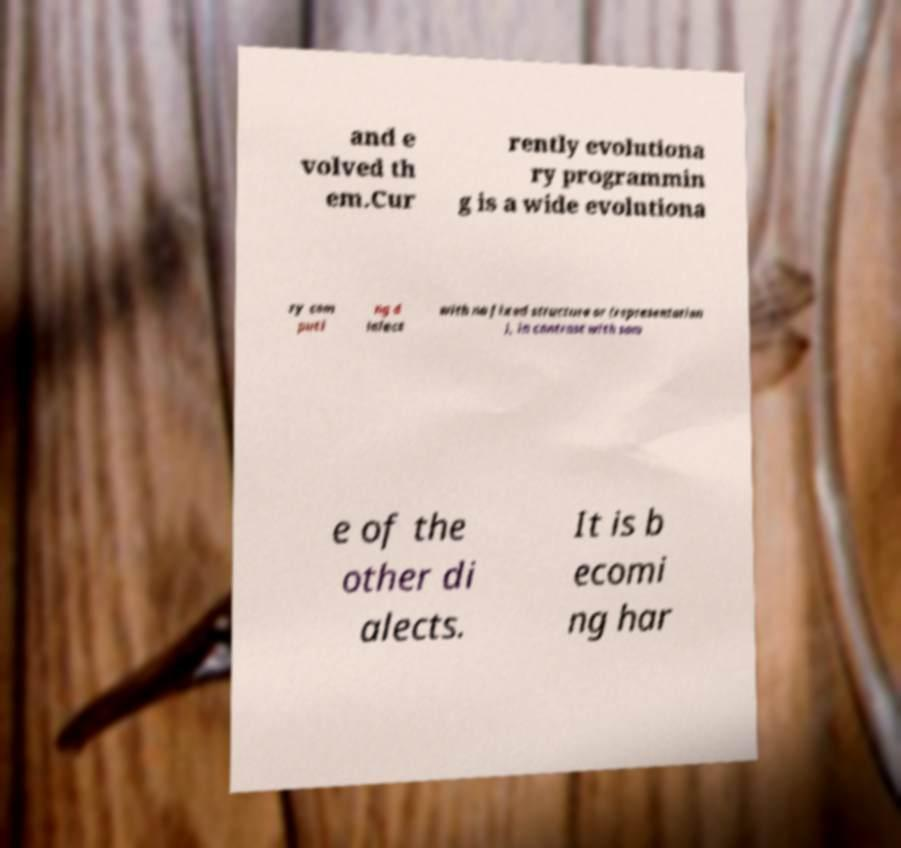Could you assist in decoding the text presented in this image and type it out clearly? and e volved th em.Cur rently evolutiona ry programmin g is a wide evolutiona ry com puti ng d ialect with no fixed structure or (representation ), in contrast with som e of the other di alects. It is b ecomi ng har 